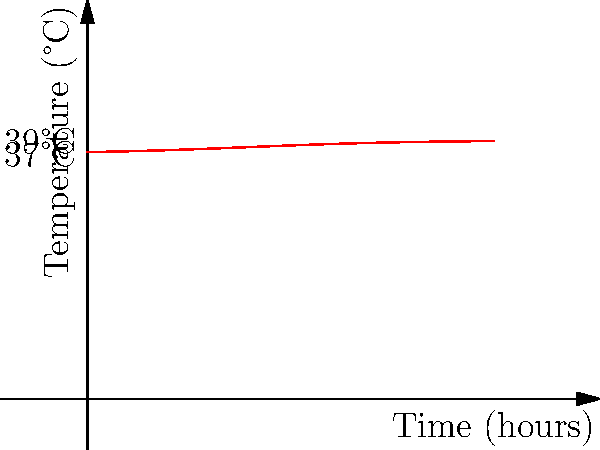The graph shows the body temperature of a child during a fever over 10 hours. Calculate the maximum rate of change in body temperature (in °C/hour) during this period. To find the maximum rate of change, we need to determine where the slope of the curve is steepest. Let's approach this step-by-step:

1) The curve represents the logistic function: $T(t) = 37 + \frac{2}{1+e^{-0.5(t-4)}}$

2) To find the rate of change, we need to differentiate $T(t)$ with respect to $t$:

   $\frac{dT}{dt} = \frac{2 \cdot 0.5 e^{-0.5(t-4)}}{(1+e^{-0.5(t-4)})^2}$

3) The maximum rate of change occurs at the inflection point of the original function, which is at $t=4$ hours (the midpoint of the logistic curve).

4) Evaluate $\frac{dT}{dt}$ at $t=4$:

   $\frac{dT}{dt}|_{t=4} = \frac{2 \cdot 0.5 e^{-0.5(4-4)}}{(1+e^{-0.5(4-4)})^2} = \frac{1}{(1+1)^2} = 0.25$

Therefore, the maximum rate of change is 0.25 °C/hour.
Answer: 0.25 °C/hour 